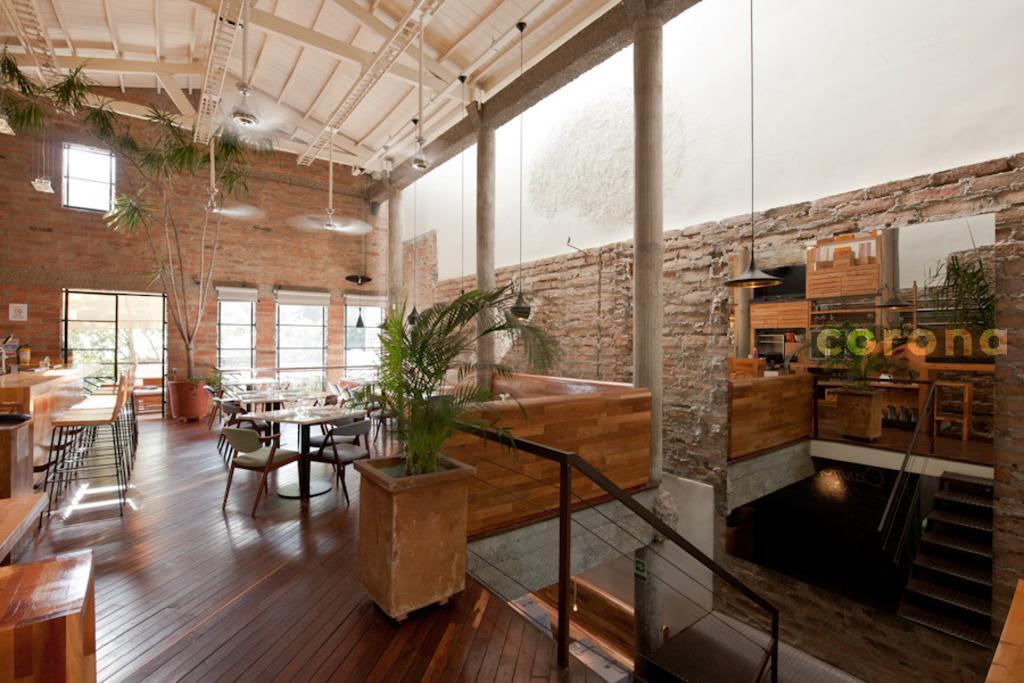How would you summarize this image in a sentence or two? This picture describes about interior view of a building, in this we can find few plants, tables, chairs and metal rods. 